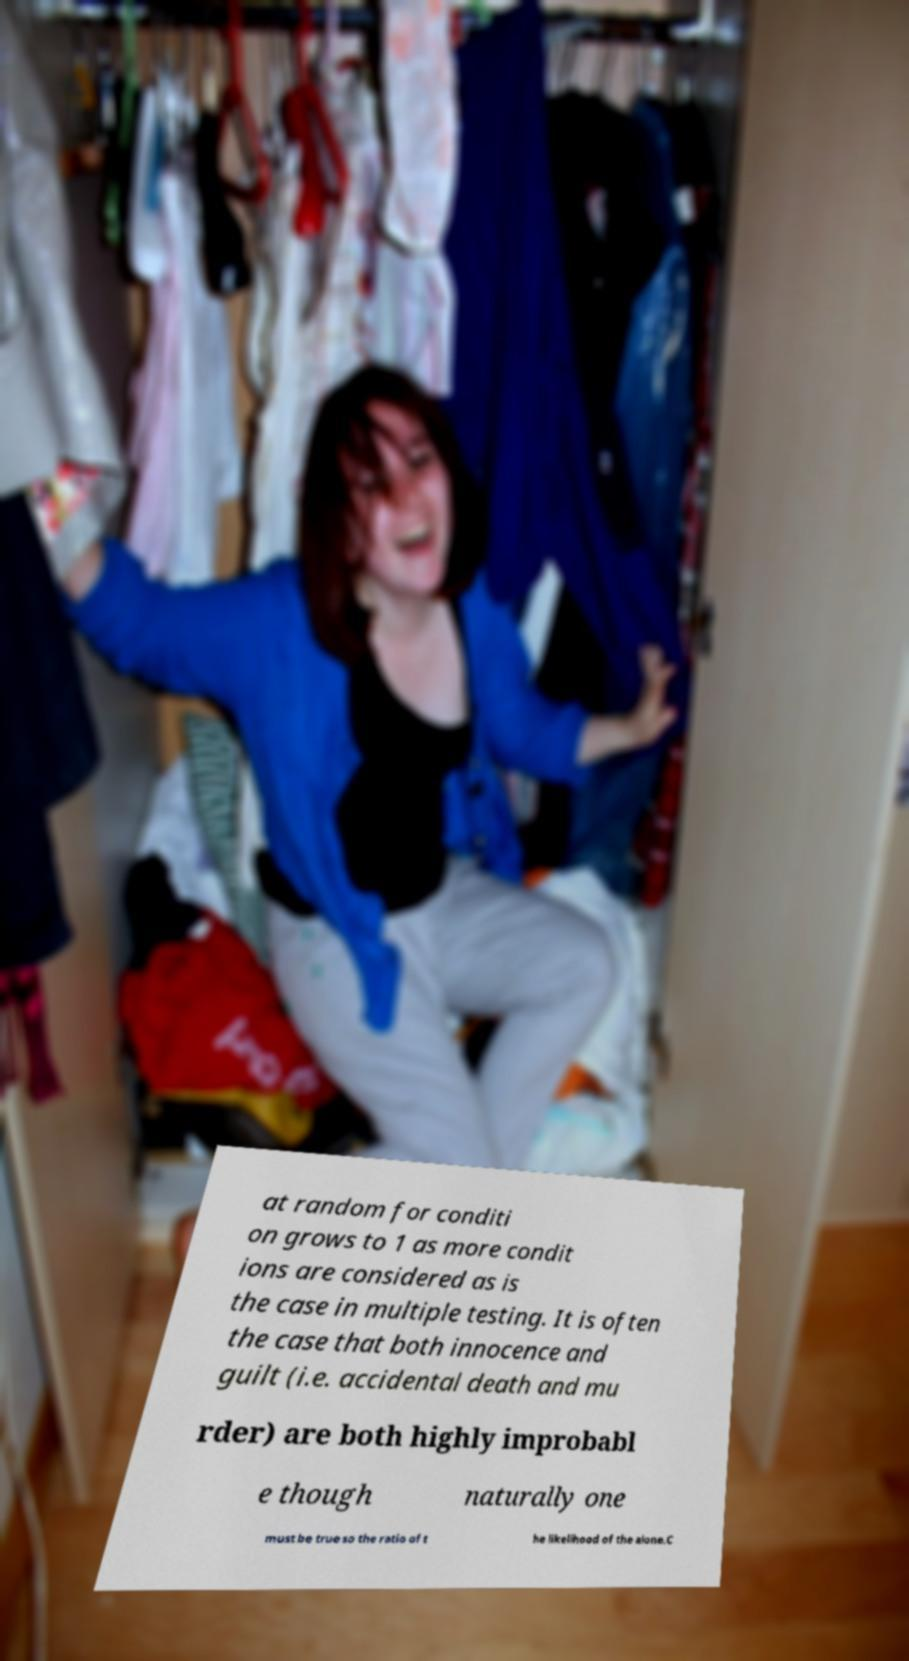Could you assist in decoding the text presented in this image and type it out clearly? at random for conditi on grows to 1 as more condit ions are considered as is the case in multiple testing. It is often the case that both innocence and guilt (i.e. accidental death and mu rder) are both highly improbabl e though naturally one must be true so the ratio of t he likelihood of the alone.C 